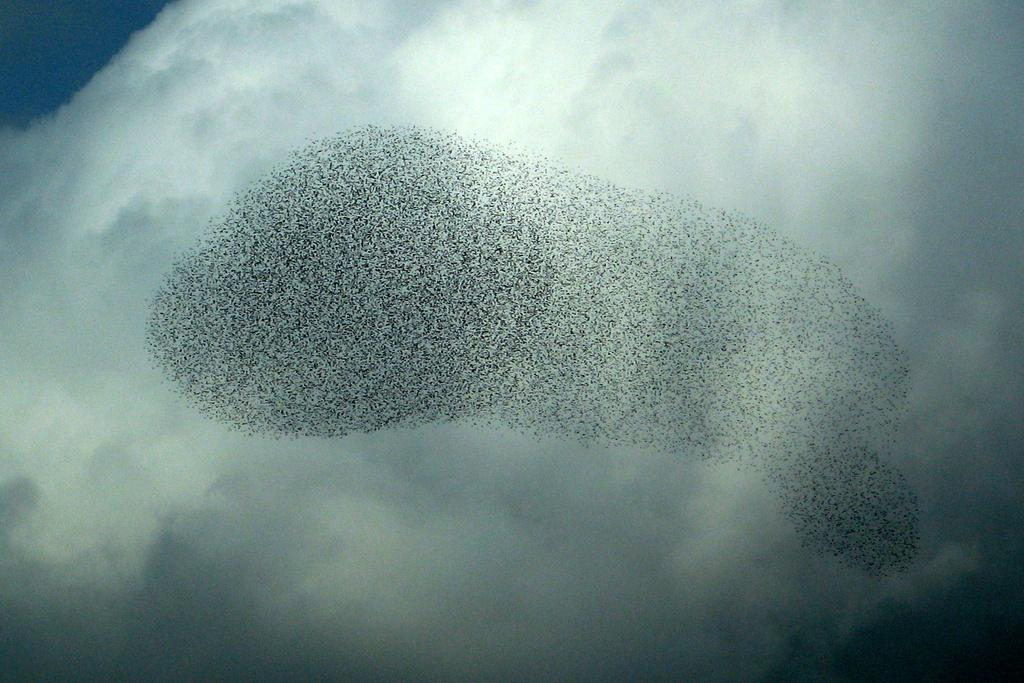What is happening in the air in the image? There are starling murmurations in the air. What can be seen in the sky in the background? There are clouds in the sky in the background. What type of fuel is being used by the stranger on the island in the image? There is no stranger or island present in the image; it features starling murmurations and clouds in the sky. 